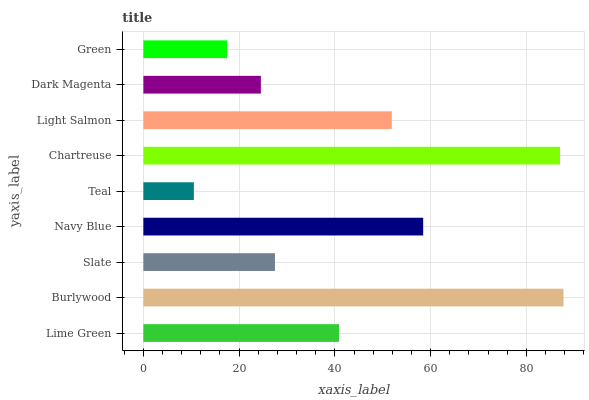Is Teal the minimum?
Answer yes or no. Yes. Is Burlywood the maximum?
Answer yes or no. Yes. Is Slate the minimum?
Answer yes or no. No. Is Slate the maximum?
Answer yes or no. No. Is Burlywood greater than Slate?
Answer yes or no. Yes. Is Slate less than Burlywood?
Answer yes or no. Yes. Is Slate greater than Burlywood?
Answer yes or no. No. Is Burlywood less than Slate?
Answer yes or no. No. Is Lime Green the high median?
Answer yes or no. Yes. Is Lime Green the low median?
Answer yes or no. Yes. Is Light Salmon the high median?
Answer yes or no. No. Is Slate the low median?
Answer yes or no. No. 